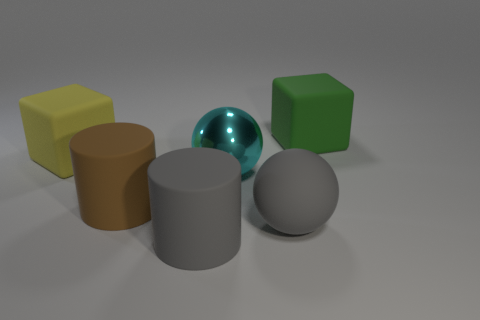Are there any duplicates of the same shape but different colors? Yes, there are two cylindrical shapes present; one is brown, and the other has a reflective surface, which appears to have a silver or grayish tone.  Can you tell me about the lighting in the image? Certainly, the lighting in the image comes from above, casting soft shadows beneath each object. It creates highlights on the tops and gentle shadow gradients on the sides, emphasizing the objects' three-dimensional forms. 